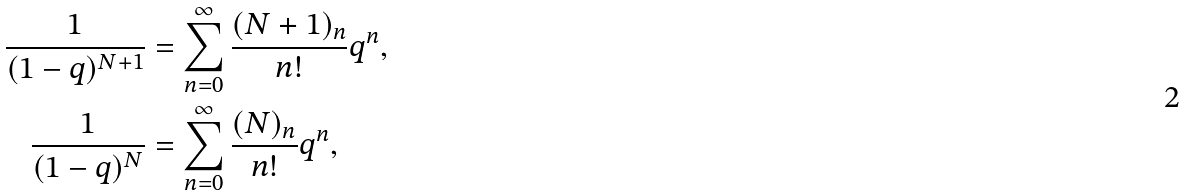<formula> <loc_0><loc_0><loc_500><loc_500>\frac { 1 } { ( 1 - q ) ^ { N + 1 } } & = \sum _ { n = 0 } ^ { \infty } \frac { ( N + 1 ) _ { n } } { n ! } q ^ { n } , \\ \frac { 1 } { ( 1 - q ) ^ { N } } & = \sum _ { n = 0 } ^ { \infty } \frac { ( N ) _ { n } } { n ! } q ^ { n } ,</formula> 